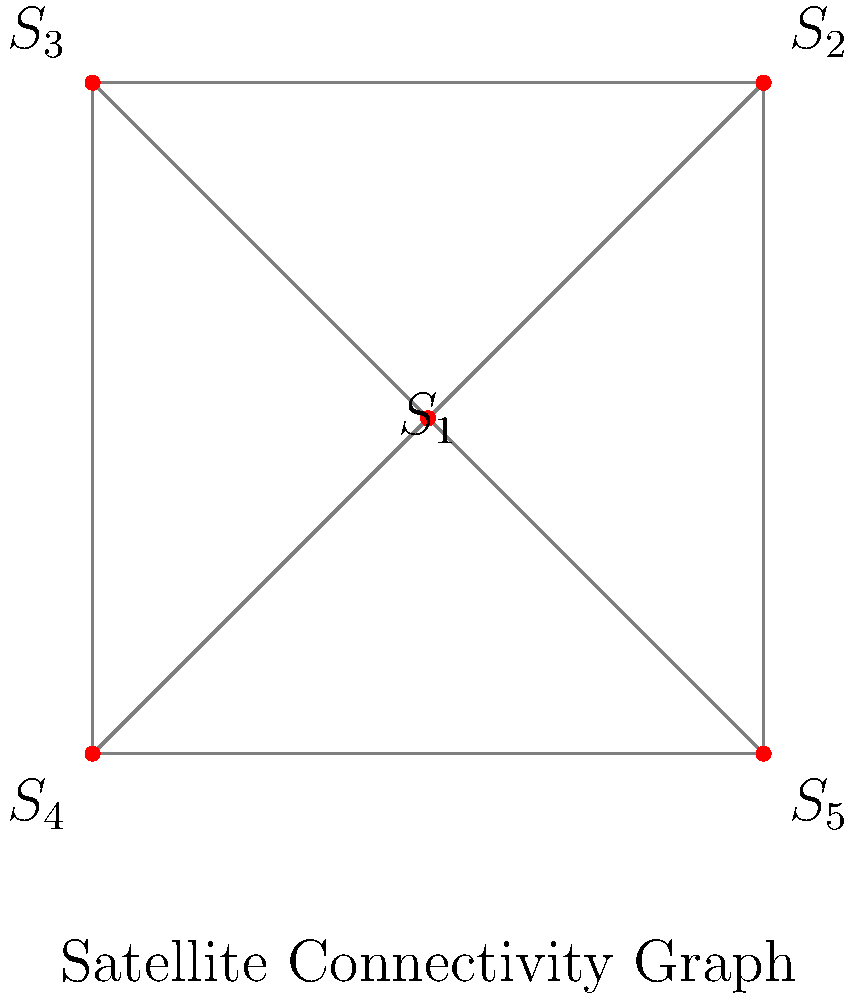In a satellite network optimization problem, you are given a graph representing the connectivity between 5 satellites ($S_1$ to $S_5$) in orbit. Each edge in the graph represents a communication link between two satellites. What is the minimum number of communication links that need to be removed to disconnect the network into two separate components, and which satellites would be in each component after this removal? To solve this problem, we need to find the minimum cut of the graph, which is equivalent to finding the graph's edge connectivity. Let's approach this step-by-step:

1) First, observe that the graph is complete (fully connected), meaning every satellite can directly communicate with every other satellite.

2) In a complete graph with $n$ vertices, the edge connectivity is equal to $n-1$. In this case, $n=5$, so the edge connectivity is 4.

3) This means we need to remove at least 4 edges to disconnect the graph into two components.

4) To achieve this minimum cut, we can isolate any single satellite from the rest. For example, we could remove all edges connected to $S_1$.

5) After removing these 4 edges, we would have two components:
   - Component 1: $\{S_1\}$
   - Component 2: $\{S_2, S_3, S_4, S_5\}$

6) Note that this is not the only solution. We could choose to isolate any of the 5 satellites and achieve the same result.

This solution is optimal because:
a) Removing fewer than 4 edges would not disconnect the graph.
b) Removing 4 edges in any other configuration would not disconnect the graph.
c) Any solution that removes more than 4 edges would not be minimal.
Answer: 4 links; $\{S_1\}$ and $\{S_2, S_3, S_4, S_5\}$ (or any single satellite isolated from the other four) 